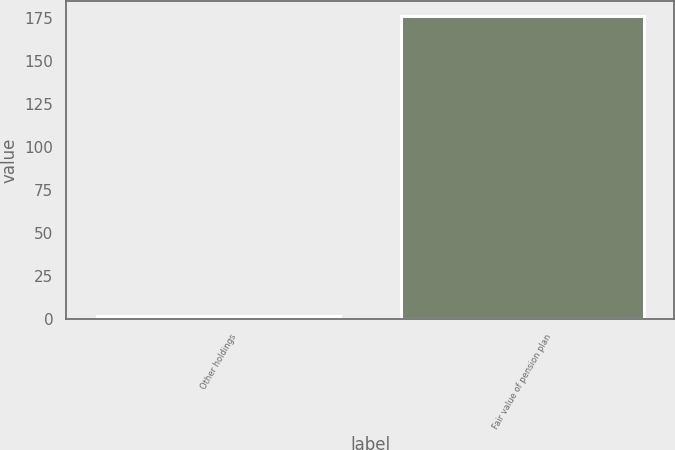Convert chart. <chart><loc_0><loc_0><loc_500><loc_500><bar_chart><fcel>Other holdings<fcel>Fair value of pension plan<nl><fcel>2<fcel>176<nl></chart> 